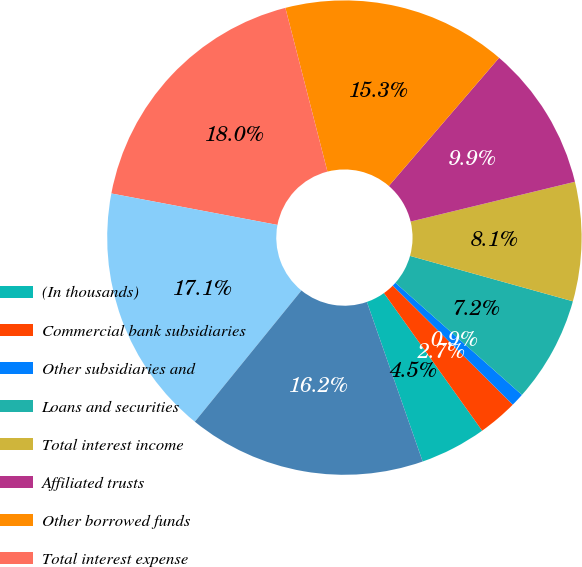<chart> <loc_0><loc_0><loc_500><loc_500><pie_chart><fcel>(In thousands)<fcel>Commercial bank subsidiaries<fcel>Other subsidiaries and<fcel>Loans and securities<fcel>Total interest income<fcel>Affiliated trusts<fcel>Other borrowed funds<fcel>Total interest expense<fcel>Net interest loss<fcel>Net interest loss after<nl><fcel>4.51%<fcel>2.7%<fcel>0.9%<fcel>7.21%<fcel>8.11%<fcel>9.91%<fcel>15.31%<fcel>18.02%<fcel>17.12%<fcel>16.21%<nl></chart> 